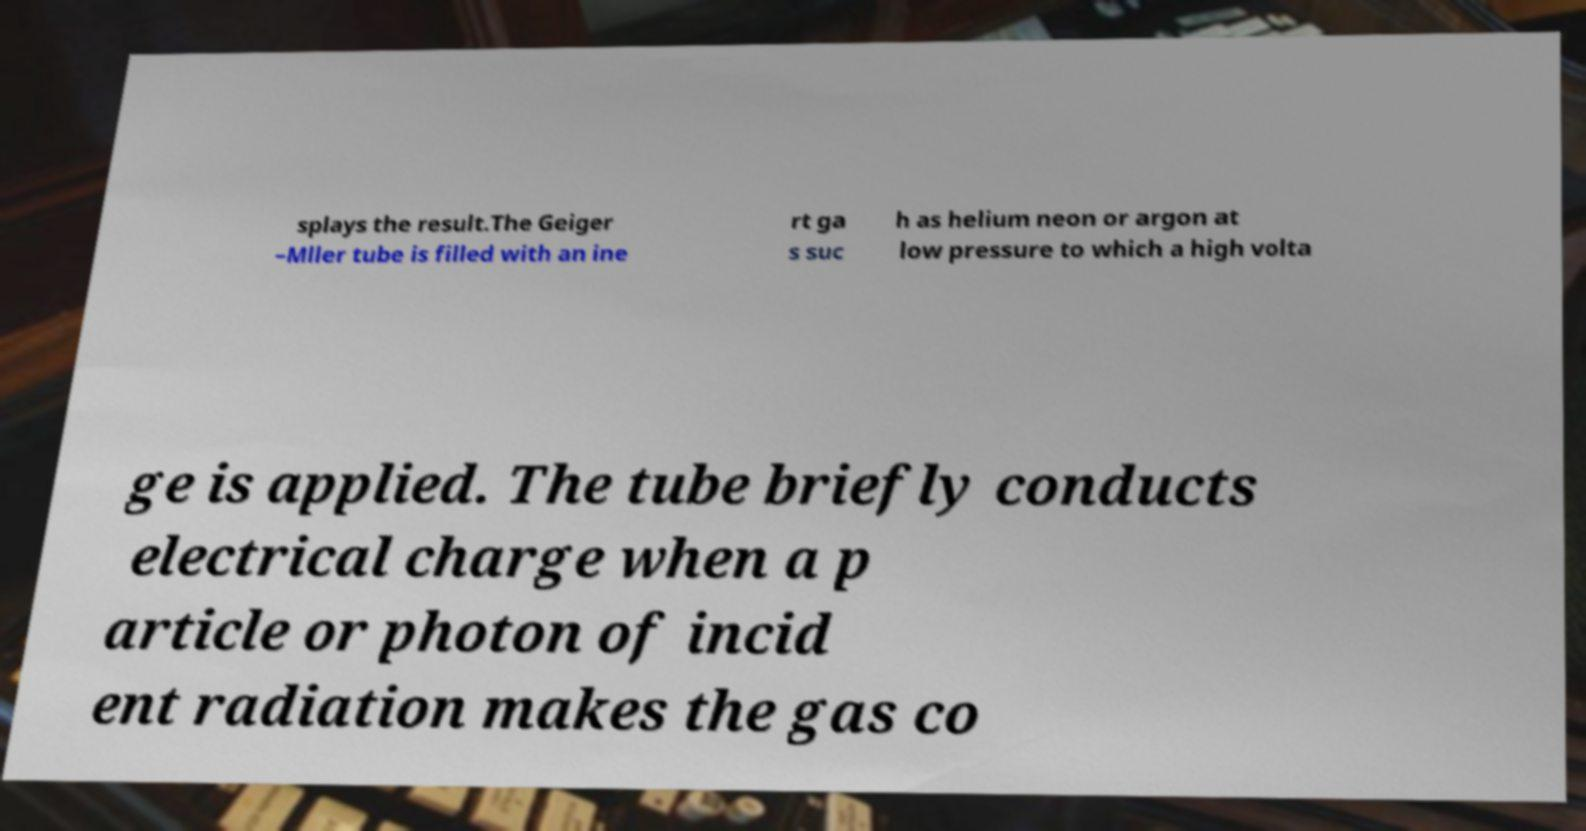Could you extract and type out the text from this image? splays the result.The Geiger –Mller tube is filled with an ine rt ga s suc h as helium neon or argon at low pressure to which a high volta ge is applied. The tube briefly conducts electrical charge when a p article or photon of incid ent radiation makes the gas co 